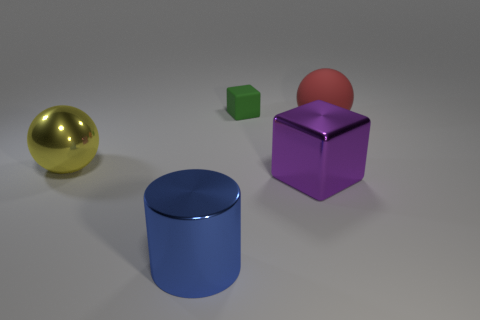There is a cube that is behind the large metal thing right of the big cylinder; how big is it?
Your answer should be compact. Small. Is there anything else that is the same size as the red matte object?
Ensure brevity in your answer.  Yes. There is another object that is the same shape as the tiny rubber thing; what material is it?
Offer a very short reply. Metal. Is the shape of the large object that is behind the yellow sphere the same as the big shiny thing that is on the right side of the green rubber thing?
Offer a terse response. No. Is the number of tiny cyan cubes greater than the number of big metallic cylinders?
Your answer should be very brief. No. What is the size of the red ball?
Provide a succinct answer. Large. Do the cube that is in front of the large shiny ball and the blue cylinder have the same material?
Provide a short and direct response. Yes. Are there fewer purple things that are in front of the large yellow ball than yellow objects on the right side of the big shiny cylinder?
Your answer should be very brief. No. How many other things are made of the same material as the yellow ball?
Offer a very short reply. 2. What material is the yellow ball that is the same size as the purple cube?
Provide a succinct answer. Metal. 